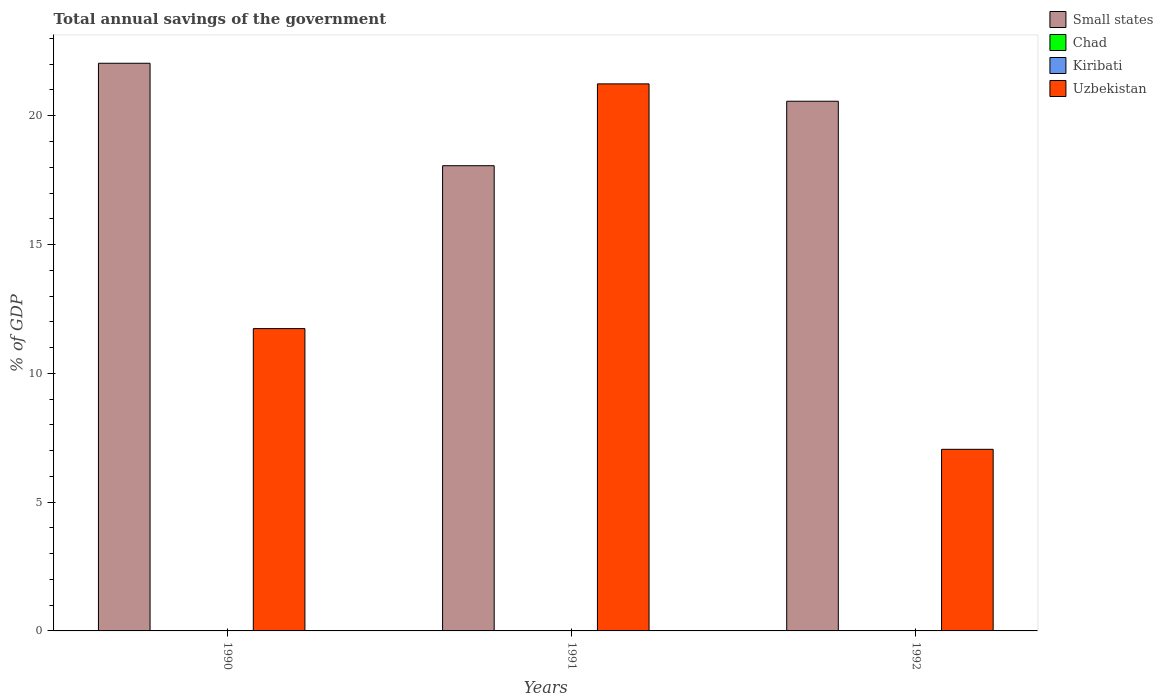How many different coloured bars are there?
Keep it short and to the point. 2. How many groups of bars are there?
Offer a very short reply. 3. How many bars are there on the 3rd tick from the right?
Your answer should be very brief. 2. What is the total annual savings of the government in Uzbekistan in 1990?
Your answer should be very brief. 11.74. Across all years, what is the maximum total annual savings of the government in Small states?
Offer a terse response. 22.04. What is the total total annual savings of the government in Uzbekistan in the graph?
Offer a terse response. 40.02. What is the difference between the total annual savings of the government in Uzbekistan in 1990 and that in 1992?
Offer a very short reply. 4.69. What is the difference between the total annual savings of the government in Chad in 1992 and the total annual savings of the government in Uzbekistan in 1990?
Provide a short and direct response. -11.74. What is the average total annual savings of the government in Kiribati per year?
Offer a very short reply. 0. In the year 1991, what is the difference between the total annual savings of the government in Uzbekistan and total annual savings of the government in Small states?
Give a very brief answer. 3.18. In how many years, is the total annual savings of the government in Small states greater than 15 %?
Keep it short and to the point. 3. What is the ratio of the total annual savings of the government in Small states in 1990 to that in 1992?
Provide a succinct answer. 1.07. What is the difference between the highest and the second highest total annual savings of the government in Uzbekistan?
Offer a terse response. 9.5. What is the difference between the highest and the lowest total annual savings of the government in Small states?
Give a very brief answer. 3.98. Is it the case that in every year, the sum of the total annual savings of the government in Small states and total annual savings of the government in Uzbekistan is greater than the sum of total annual savings of the government in Kiribati and total annual savings of the government in Chad?
Offer a very short reply. No. Is it the case that in every year, the sum of the total annual savings of the government in Small states and total annual savings of the government in Uzbekistan is greater than the total annual savings of the government in Chad?
Your response must be concise. Yes. What is the difference between two consecutive major ticks on the Y-axis?
Provide a short and direct response. 5. Does the graph contain grids?
Your answer should be very brief. No. Where does the legend appear in the graph?
Your answer should be very brief. Top right. What is the title of the graph?
Provide a short and direct response. Total annual savings of the government. What is the label or title of the Y-axis?
Give a very brief answer. % of GDP. What is the % of GDP in Small states in 1990?
Your answer should be very brief. 22.04. What is the % of GDP in Kiribati in 1990?
Provide a short and direct response. 0. What is the % of GDP in Uzbekistan in 1990?
Offer a terse response. 11.74. What is the % of GDP of Small states in 1991?
Provide a short and direct response. 18.06. What is the % of GDP of Kiribati in 1991?
Make the answer very short. 0. What is the % of GDP of Uzbekistan in 1991?
Ensure brevity in your answer.  21.24. What is the % of GDP in Small states in 1992?
Make the answer very short. 20.56. What is the % of GDP in Kiribati in 1992?
Give a very brief answer. 0. What is the % of GDP in Uzbekistan in 1992?
Ensure brevity in your answer.  7.05. Across all years, what is the maximum % of GDP in Small states?
Ensure brevity in your answer.  22.04. Across all years, what is the maximum % of GDP in Uzbekistan?
Offer a very short reply. 21.24. Across all years, what is the minimum % of GDP in Small states?
Offer a very short reply. 18.06. Across all years, what is the minimum % of GDP of Uzbekistan?
Give a very brief answer. 7.05. What is the total % of GDP in Small states in the graph?
Make the answer very short. 60.66. What is the total % of GDP in Chad in the graph?
Make the answer very short. 0. What is the total % of GDP of Uzbekistan in the graph?
Provide a short and direct response. 40.02. What is the difference between the % of GDP in Small states in 1990 and that in 1991?
Offer a terse response. 3.98. What is the difference between the % of GDP in Uzbekistan in 1990 and that in 1991?
Offer a terse response. -9.5. What is the difference between the % of GDP of Small states in 1990 and that in 1992?
Make the answer very short. 1.47. What is the difference between the % of GDP of Uzbekistan in 1990 and that in 1992?
Your response must be concise. 4.69. What is the difference between the % of GDP of Small states in 1991 and that in 1992?
Your answer should be compact. -2.5. What is the difference between the % of GDP of Uzbekistan in 1991 and that in 1992?
Provide a succinct answer. 14.19. What is the difference between the % of GDP in Small states in 1990 and the % of GDP in Uzbekistan in 1991?
Keep it short and to the point. 0.8. What is the difference between the % of GDP of Small states in 1990 and the % of GDP of Uzbekistan in 1992?
Your answer should be compact. 14.99. What is the difference between the % of GDP in Small states in 1991 and the % of GDP in Uzbekistan in 1992?
Make the answer very short. 11.01. What is the average % of GDP of Small states per year?
Ensure brevity in your answer.  20.22. What is the average % of GDP in Uzbekistan per year?
Offer a very short reply. 13.34. In the year 1990, what is the difference between the % of GDP of Small states and % of GDP of Uzbekistan?
Make the answer very short. 10.3. In the year 1991, what is the difference between the % of GDP in Small states and % of GDP in Uzbekistan?
Your response must be concise. -3.18. In the year 1992, what is the difference between the % of GDP of Small states and % of GDP of Uzbekistan?
Keep it short and to the point. 13.51. What is the ratio of the % of GDP of Small states in 1990 to that in 1991?
Provide a short and direct response. 1.22. What is the ratio of the % of GDP in Uzbekistan in 1990 to that in 1991?
Offer a very short reply. 0.55. What is the ratio of the % of GDP in Small states in 1990 to that in 1992?
Provide a succinct answer. 1.07. What is the ratio of the % of GDP in Uzbekistan in 1990 to that in 1992?
Offer a terse response. 1.66. What is the ratio of the % of GDP of Small states in 1991 to that in 1992?
Offer a terse response. 0.88. What is the ratio of the % of GDP in Uzbekistan in 1991 to that in 1992?
Offer a terse response. 3.01. What is the difference between the highest and the second highest % of GDP in Small states?
Make the answer very short. 1.47. What is the difference between the highest and the second highest % of GDP of Uzbekistan?
Give a very brief answer. 9.5. What is the difference between the highest and the lowest % of GDP of Small states?
Your answer should be compact. 3.98. What is the difference between the highest and the lowest % of GDP of Uzbekistan?
Offer a very short reply. 14.19. 